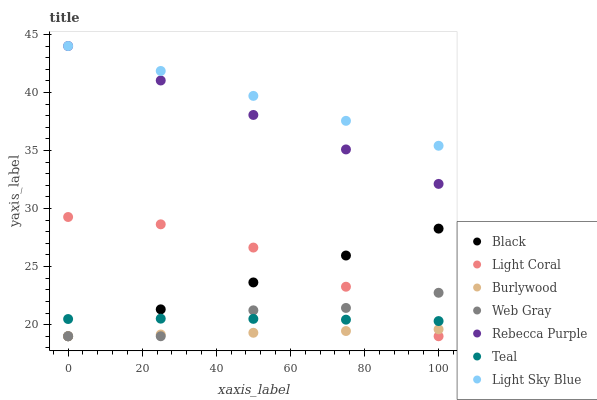Does Burlywood have the minimum area under the curve?
Answer yes or no. Yes. Does Light Sky Blue have the maximum area under the curve?
Answer yes or no. Yes. Does Light Coral have the minimum area under the curve?
Answer yes or no. No. Does Light Coral have the maximum area under the curve?
Answer yes or no. No. Is Rebecca Purple the smoothest?
Answer yes or no. Yes. Is Web Gray the roughest?
Answer yes or no. Yes. Is Burlywood the smoothest?
Answer yes or no. No. Is Burlywood the roughest?
Answer yes or no. No. Does Web Gray have the lowest value?
Answer yes or no. Yes. Does Light Sky Blue have the lowest value?
Answer yes or no. No. Does Rebecca Purple have the highest value?
Answer yes or no. Yes. Does Light Coral have the highest value?
Answer yes or no. No. Is Burlywood less than Teal?
Answer yes or no. Yes. Is Light Sky Blue greater than Light Coral?
Answer yes or no. Yes. Does Web Gray intersect Black?
Answer yes or no. Yes. Is Web Gray less than Black?
Answer yes or no. No. Is Web Gray greater than Black?
Answer yes or no. No. Does Burlywood intersect Teal?
Answer yes or no. No. 